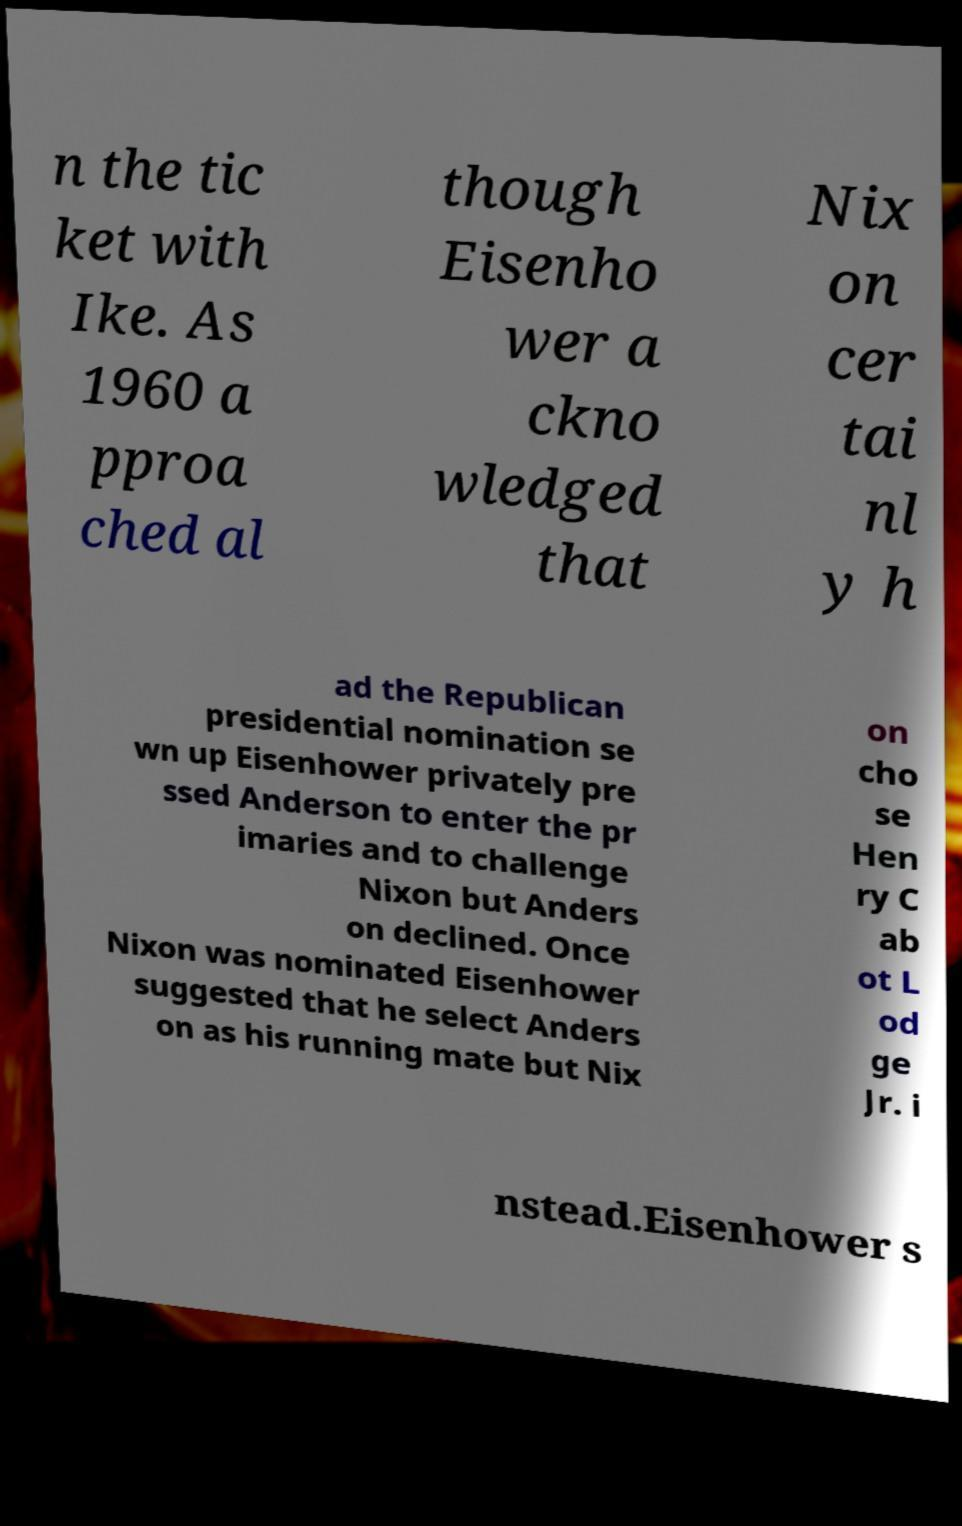For documentation purposes, I need the text within this image transcribed. Could you provide that? n the tic ket with Ike. As 1960 a pproa ched al though Eisenho wer a ckno wledged that Nix on cer tai nl y h ad the Republican presidential nomination se wn up Eisenhower privately pre ssed Anderson to enter the pr imaries and to challenge Nixon but Anders on declined. Once Nixon was nominated Eisenhower suggested that he select Anders on as his running mate but Nix on cho se Hen ry C ab ot L od ge Jr. i nstead.Eisenhower s 